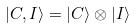Convert formula to latex. <formula><loc_0><loc_0><loc_500><loc_500>| C , I \rangle = | C \rangle \otimes | I \rangle \,</formula> 